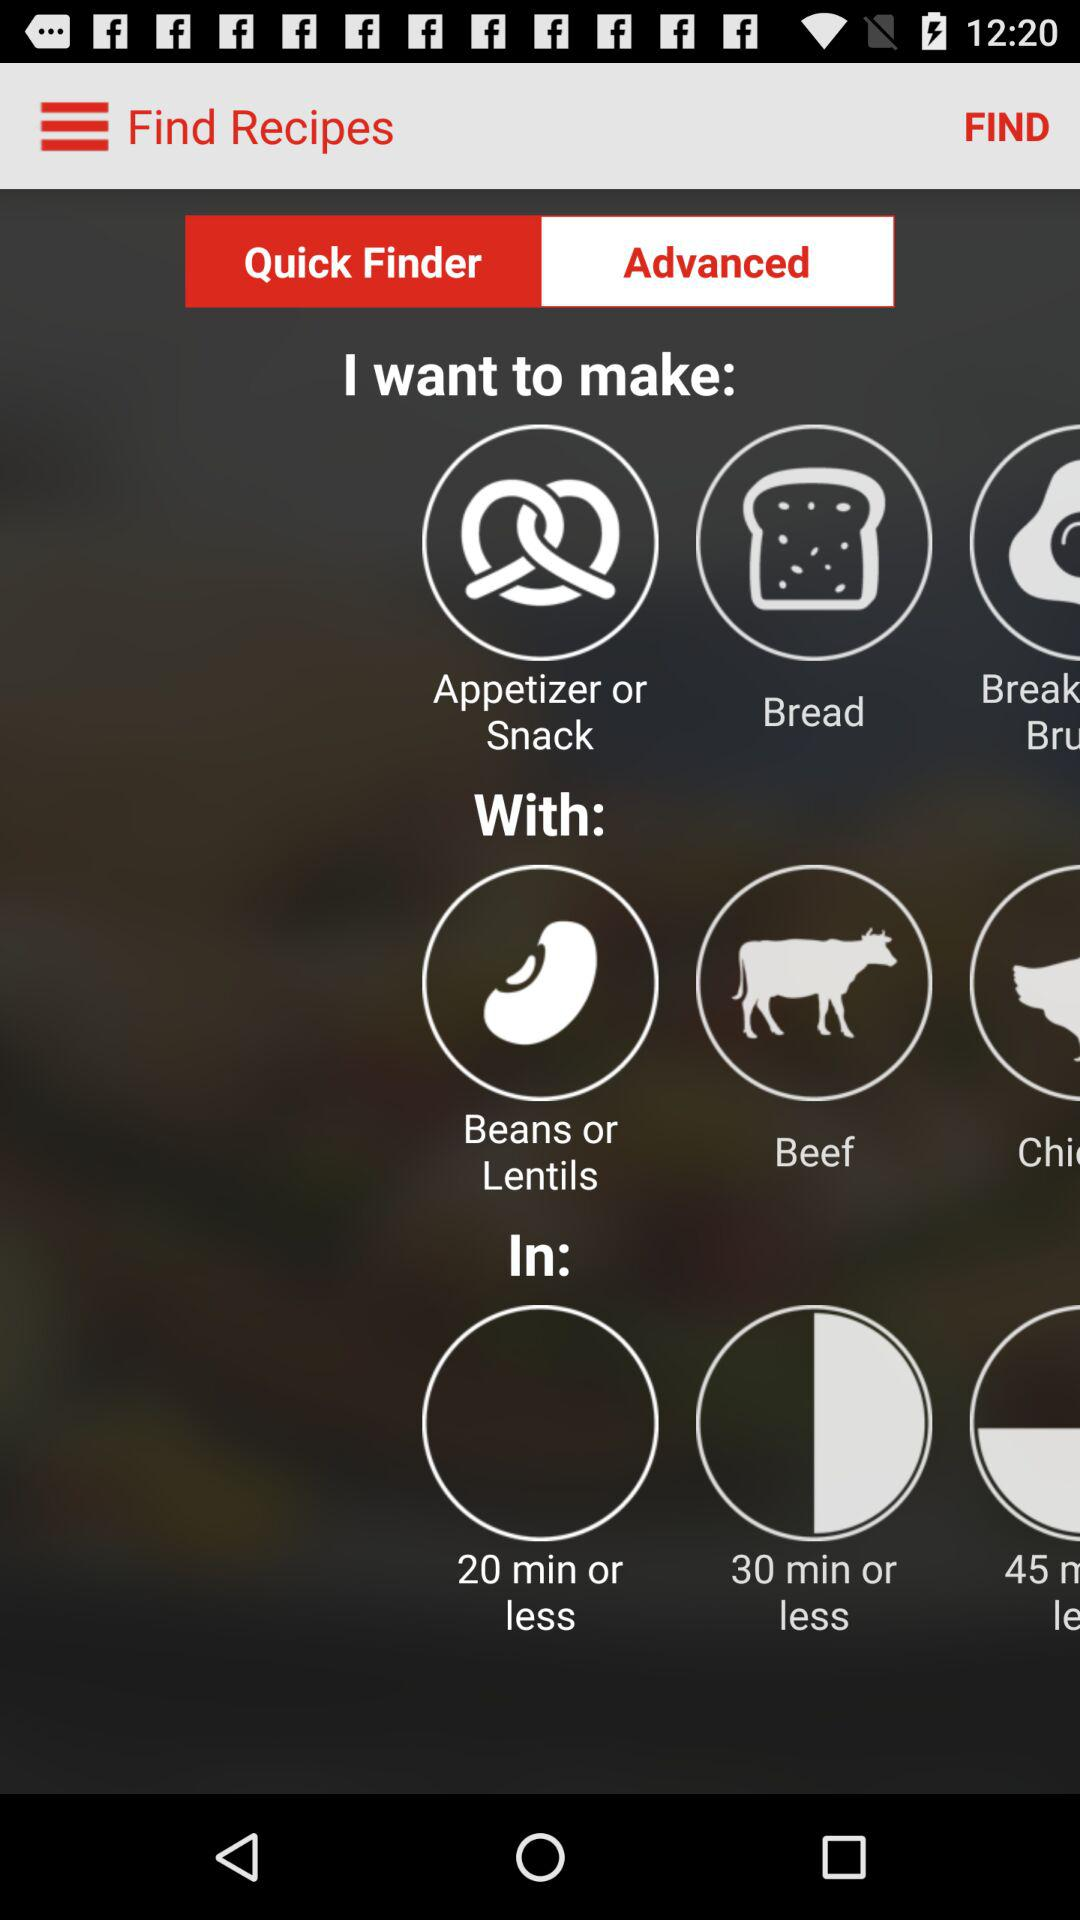Which tab is selected? The selected tab is "Quick Finder". 